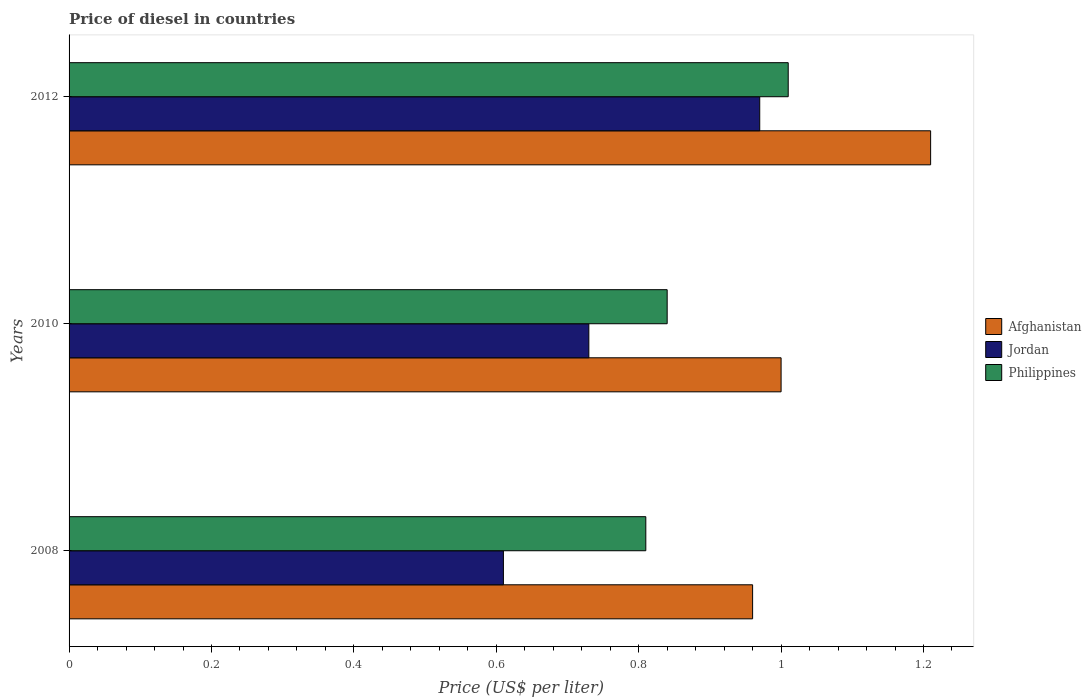Are the number of bars per tick equal to the number of legend labels?
Offer a terse response. Yes. How many bars are there on the 3rd tick from the top?
Offer a terse response. 3. How many bars are there on the 2nd tick from the bottom?
Ensure brevity in your answer.  3. What is the label of the 1st group of bars from the top?
Keep it short and to the point. 2012. What is the price of diesel in Jordan in 2008?
Offer a terse response. 0.61. Across all years, what is the maximum price of diesel in Afghanistan?
Provide a succinct answer. 1.21. Across all years, what is the minimum price of diesel in Jordan?
Ensure brevity in your answer.  0.61. In which year was the price of diesel in Philippines minimum?
Offer a very short reply. 2008. What is the total price of diesel in Philippines in the graph?
Keep it short and to the point. 2.66. What is the difference between the price of diesel in Jordan in 2008 and that in 2010?
Provide a succinct answer. -0.12. What is the difference between the price of diesel in Jordan in 2008 and the price of diesel in Philippines in 2012?
Your answer should be very brief. -0.4. What is the average price of diesel in Afghanistan per year?
Give a very brief answer. 1.06. In the year 2010, what is the difference between the price of diesel in Jordan and price of diesel in Afghanistan?
Provide a short and direct response. -0.27. In how many years, is the price of diesel in Jordan greater than 1 US$?
Make the answer very short. 0. What is the ratio of the price of diesel in Jordan in 2008 to that in 2012?
Make the answer very short. 0.63. Is the price of diesel in Philippines in 2008 less than that in 2012?
Offer a very short reply. Yes. Is the difference between the price of diesel in Jordan in 2010 and 2012 greater than the difference between the price of diesel in Afghanistan in 2010 and 2012?
Provide a short and direct response. No. What is the difference between the highest and the second highest price of diesel in Afghanistan?
Give a very brief answer. 0.21. What is the difference between the highest and the lowest price of diesel in Philippines?
Offer a terse response. 0.2. What does the 2nd bar from the bottom in 2010 represents?
Offer a very short reply. Jordan. Is it the case that in every year, the sum of the price of diesel in Afghanistan and price of diesel in Philippines is greater than the price of diesel in Jordan?
Give a very brief answer. Yes. How many bars are there?
Give a very brief answer. 9. How many years are there in the graph?
Your answer should be very brief. 3. What is the difference between two consecutive major ticks on the X-axis?
Provide a short and direct response. 0.2. Are the values on the major ticks of X-axis written in scientific E-notation?
Your answer should be very brief. No. Does the graph contain any zero values?
Give a very brief answer. No. Where does the legend appear in the graph?
Make the answer very short. Center right. How many legend labels are there?
Provide a succinct answer. 3. How are the legend labels stacked?
Give a very brief answer. Vertical. What is the title of the graph?
Offer a very short reply. Price of diesel in countries. Does "Paraguay" appear as one of the legend labels in the graph?
Offer a very short reply. No. What is the label or title of the X-axis?
Offer a very short reply. Price (US$ per liter). What is the Price (US$ per liter) of Afghanistan in 2008?
Provide a succinct answer. 0.96. What is the Price (US$ per liter) of Jordan in 2008?
Keep it short and to the point. 0.61. What is the Price (US$ per liter) in Philippines in 2008?
Provide a short and direct response. 0.81. What is the Price (US$ per liter) in Jordan in 2010?
Offer a very short reply. 0.73. What is the Price (US$ per liter) of Philippines in 2010?
Your response must be concise. 0.84. What is the Price (US$ per liter) in Afghanistan in 2012?
Make the answer very short. 1.21. What is the Price (US$ per liter) in Jordan in 2012?
Give a very brief answer. 0.97. What is the Price (US$ per liter) in Philippines in 2012?
Ensure brevity in your answer.  1.01. Across all years, what is the maximum Price (US$ per liter) of Afghanistan?
Provide a succinct answer. 1.21. Across all years, what is the maximum Price (US$ per liter) in Jordan?
Your answer should be very brief. 0.97. Across all years, what is the minimum Price (US$ per liter) of Jordan?
Provide a succinct answer. 0.61. Across all years, what is the minimum Price (US$ per liter) in Philippines?
Offer a terse response. 0.81. What is the total Price (US$ per liter) in Afghanistan in the graph?
Ensure brevity in your answer.  3.17. What is the total Price (US$ per liter) of Jordan in the graph?
Provide a succinct answer. 2.31. What is the total Price (US$ per liter) of Philippines in the graph?
Your answer should be very brief. 2.66. What is the difference between the Price (US$ per liter) in Afghanistan in 2008 and that in 2010?
Offer a terse response. -0.04. What is the difference between the Price (US$ per liter) of Jordan in 2008 and that in 2010?
Ensure brevity in your answer.  -0.12. What is the difference between the Price (US$ per liter) of Philippines in 2008 and that in 2010?
Your answer should be very brief. -0.03. What is the difference between the Price (US$ per liter) in Jordan in 2008 and that in 2012?
Offer a terse response. -0.36. What is the difference between the Price (US$ per liter) in Afghanistan in 2010 and that in 2012?
Offer a terse response. -0.21. What is the difference between the Price (US$ per liter) of Jordan in 2010 and that in 2012?
Provide a succinct answer. -0.24. What is the difference between the Price (US$ per liter) in Philippines in 2010 and that in 2012?
Your answer should be very brief. -0.17. What is the difference between the Price (US$ per liter) of Afghanistan in 2008 and the Price (US$ per liter) of Jordan in 2010?
Make the answer very short. 0.23. What is the difference between the Price (US$ per liter) in Afghanistan in 2008 and the Price (US$ per liter) in Philippines in 2010?
Make the answer very short. 0.12. What is the difference between the Price (US$ per liter) in Jordan in 2008 and the Price (US$ per liter) in Philippines in 2010?
Make the answer very short. -0.23. What is the difference between the Price (US$ per liter) in Afghanistan in 2008 and the Price (US$ per liter) in Jordan in 2012?
Make the answer very short. -0.01. What is the difference between the Price (US$ per liter) in Afghanistan in 2010 and the Price (US$ per liter) in Jordan in 2012?
Offer a terse response. 0.03. What is the difference between the Price (US$ per liter) in Afghanistan in 2010 and the Price (US$ per liter) in Philippines in 2012?
Provide a short and direct response. -0.01. What is the difference between the Price (US$ per liter) of Jordan in 2010 and the Price (US$ per liter) of Philippines in 2012?
Keep it short and to the point. -0.28. What is the average Price (US$ per liter) of Afghanistan per year?
Ensure brevity in your answer.  1.06. What is the average Price (US$ per liter) of Jordan per year?
Your answer should be very brief. 0.77. What is the average Price (US$ per liter) in Philippines per year?
Offer a terse response. 0.89. In the year 2008, what is the difference between the Price (US$ per liter) of Afghanistan and Price (US$ per liter) of Jordan?
Offer a terse response. 0.35. In the year 2008, what is the difference between the Price (US$ per liter) in Afghanistan and Price (US$ per liter) in Philippines?
Your answer should be compact. 0.15. In the year 2008, what is the difference between the Price (US$ per liter) in Jordan and Price (US$ per liter) in Philippines?
Your response must be concise. -0.2. In the year 2010, what is the difference between the Price (US$ per liter) in Afghanistan and Price (US$ per liter) in Jordan?
Give a very brief answer. 0.27. In the year 2010, what is the difference between the Price (US$ per liter) of Afghanistan and Price (US$ per liter) of Philippines?
Give a very brief answer. 0.16. In the year 2010, what is the difference between the Price (US$ per liter) in Jordan and Price (US$ per liter) in Philippines?
Keep it short and to the point. -0.11. In the year 2012, what is the difference between the Price (US$ per liter) in Afghanistan and Price (US$ per liter) in Jordan?
Keep it short and to the point. 0.24. In the year 2012, what is the difference between the Price (US$ per liter) of Jordan and Price (US$ per liter) of Philippines?
Give a very brief answer. -0.04. What is the ratio of the Price (US$ per liter) of Afghanistan in 2008 to that in 2010?
Give a very brief answer. 0.96. What is the ratio of the Price (US$ per liter) of Jordan in 2008 to that in 2010?
Keep it short and to the point. 0.84. What is the ratio of the Price (US$ per liter) in Philippines in 2008 to that in 2010?
Give a very brief answer. 0.96. What is the ratio of the Price (US$ per liter) of Afghanistan in 2008 to that in 2012?
Make the answer very short. 0.79. What is the ratio of the Price (US$ per liter) in Jordan in 2008 to that in 2012?
Offer a terse response. 0.63. What is the ratio of the Price (US$ per liter) of Philippines in 2008 to that in 2012?
Give a very brief answer. 0.8. What is the ratio of the Price (US$ per liter) in Afghanistan in 2010 to that in 2012?
Your answer should be very brief. 0.83. What is the ratio of the Price (US$ per liter) in Jordan in 2010 to that in 2012?
Your answer should be very brief. 0.75. What is the ratio of the Price (US$ per liter) in Philippines in 2010 to that in 2012?
Provide a short and direct response. 0.83. What is the difference between the highest and the second highest Price (US$ per liter) in Afghanistan?
Offer a terse response. 0.21. What is the difference between the highest and the second highest Price (US$ per liter) of Jordan?
Offer a terse response. 0.24. What is the difference between the highest and the second highest Price (US$ per liter) in Philippines?
Give a very brief answer. 0.17. What is the difference between the highest and the lowest Price (US$ per liter) of Afghanistan?
Give a very brief answer. 0.25. What is the difference between the highest and the lowest Price (US$ per liter) of Jordan?
Provide a short and direct response. 0.36. What is the difference between the highest and the lowest Price (US$ per liter) in Philippines?
Make the answer very short. 0.2. 